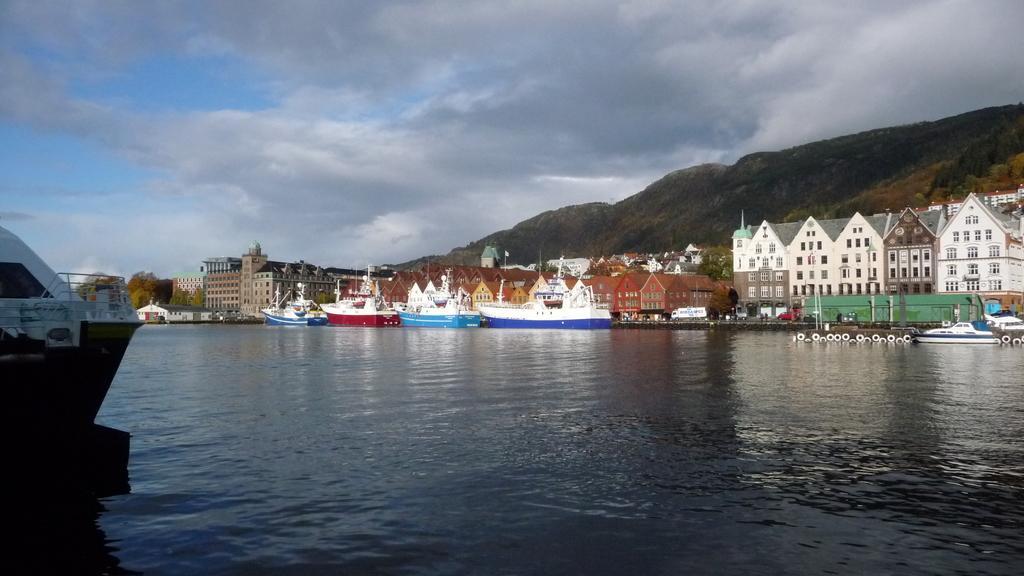Please provide a concise description of this image. In this image, on the left side, we can see a boat drowning on the water. On the right side, we can see some buildings, boats, trees, mountains, rocks. At the top, we can see a sky, at the bottom, we can see a water in a lake. 